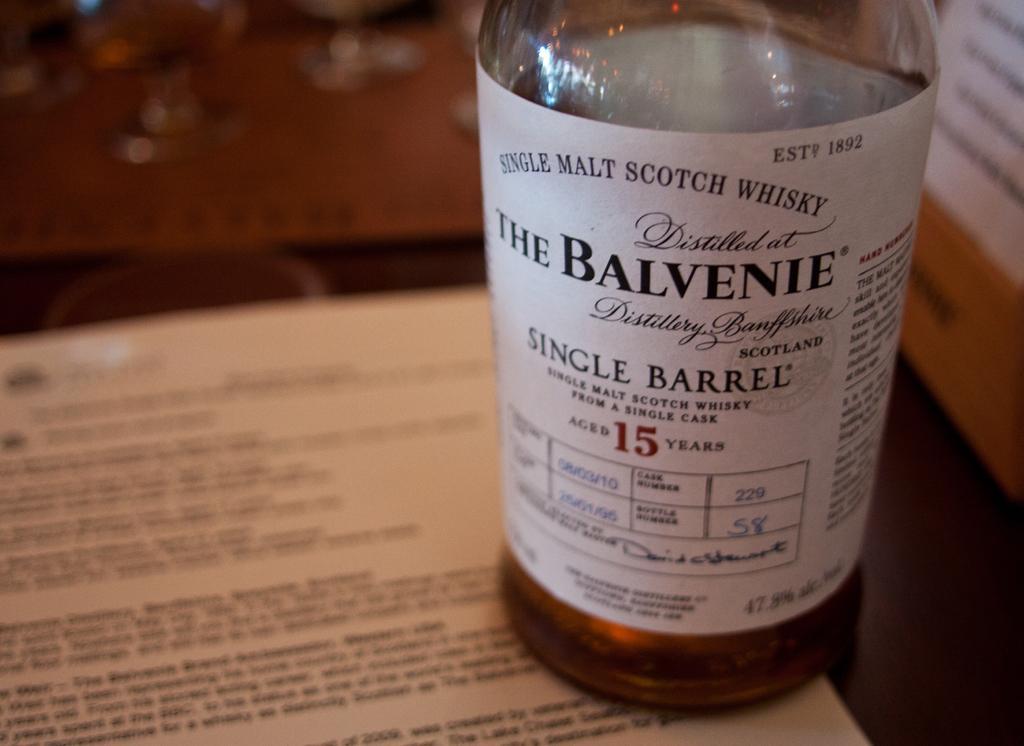How would you summarize this image in a sentence or two? In this image i can see a table on which there is a paper, few glasses and a bottle with liquid in it, and a sticker attached to the bottle. 